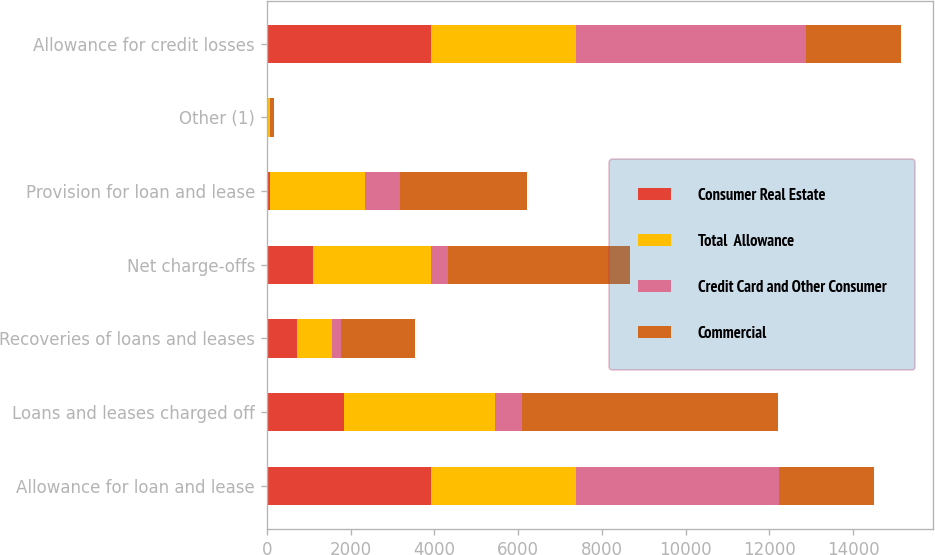Convert chart to OTSL. <chart><loc_0><loc_0><loc_500><loc_500><stacked_bar_chart><ecel><fcel>Allowance for loan and lease<fcel>Loans and leases charged off<fcel>Recoveries of loans and leases<fcel>Net charge-offs<fcel>Provision for loan and lease<fcel>Other (1)<fcel>Allowance for credit losses<nl><fcel>Consumer Real Estate<fcel>3914<fcel>1841<fcel>732<fcel>1109<fcel>70<fcel>34<fcel>3914<nl><fcel>Total  Allowance<fcel>3471<fcel>3620<fcel>813<fcel>2807<fcel>2278<fcel>47<fcel>3471<nl><fcel>Credit Card and Other Consumer<fcel>4849<fcel>644<fcel>222<fcel>422<fcel>835<fcel>1<fcel>5495<nl><fcel>Commercial<fcel>2278<fcel>6105<fcel>1767<fcel>4338<fcel>3043<fcel>82<fcel>2278<nl></chart> 